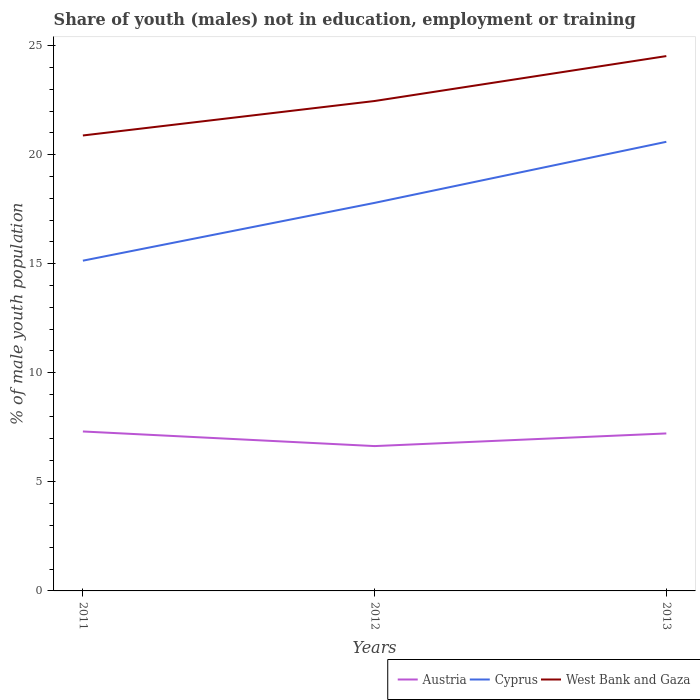Across all years, what is the maximum percentage of unemployed males population in in Austria?
Give a very brief answer. 6.64. What is the total percentage of unemployed males population in in West Bank and Gaza in the graph?
Ensure brevity in your answer.  -3.64. What is the difference between the highest and the second highest percentage of unemployed males population in in Cyprus?
Your answer should be very brief. 5.45. How many lines are there?
Your response must be concise. 3. How many years are there in the graph?
Your answer should be very brief. 3. What is the difference between two consecutive major ticks on the Y-axis?
Provide a succinct answer. 5. Are the values on the major ticks of Y-axis written in scientific E-notation?
Offer a terse response. No. Where does the legend appear in the graph?
Keep it short and to the point. Bottom right. What is the title of the graph?
Keep it short and to the point. Share of youth (males) not in education, employment or training. Does "Aruba" appear as one of the legend labels in the graph?
Provide a succinct answer. No. What is the label or title of the Y-axis?
Ensure brevity in your answer.  % of male youth population. What is the % of male youth population in Austria in 2011?
Offer a terse response. 7.31. What is the % of male youth population in Cyprus in 2011?
Provide a succinct answer. 15.14. What is the % of male youth population of West Bank and Gaza in 2011?
Your answer should be very brief. 20.88. What is the % of male youth population of Austria in 2012?
Ensure brevity in your answer.  6.64. What is the % of male youth population in Cyprus in 2012?
Provide a succinct answer. 17.79. What is the % of male youth population of West Bank and Gaza in 2012?
Offer a terse response. 22.46. What is the % of male youth population in Austria in 2013?
Keep it short and to the point. 7.22. What is the % of male youth population in Cyprus in 2013?
Offer a terse response. 20.59. What is the % of male youth population in West Bank and Gaza in 2013?
Keep it short and to the point. 24.52. Across all years, what is the maximum % of male youth population of Austria?
Your answer should be compact. 7.31. Across all years, what is the maximum % of male youth population in Cyprus?
Keep it short and to the point. 20.59. Across all years, what is the maximum % of male youth population in West Bank and Gaza?
Give a very brief answer. 24.52. Across all years, what is the minimum % of male youth population in Austria?
Provide a short and direct response. 6.64. Across all years, what is the minimum % of male youth population of Cyprus?
Your answer should be very brief. 15.14. Across all years, what is the minimum % of male youth population of West Bank and Gaza?
Give a very brief answer. 20.88. What is the total % of male youth population in Austria in the graph?
Provide a succinct answer. 21.17. What is the total % of male youth population of Cyprus in the graph?
Give a very brief answer. 53.52. What is the total % of male youth population of West Bank and Gaza in the graph?
Your answer should be very brief. 67.86. What is the difference between the % of male youth population in Austria in 2011 and that in 2012?
Your response must be concise. 0.67. What is the difference between the % of male youth population of Cyprus in 2011 and that in 2012?
Your answer should be compact. -2.65. What is the difference between the % of male youth population in West Bank and Gaza in 2011 and that in 2012?
Your answer should be compact. -1.58. What is the difference between the % of male youth population in Austria in 2011 and that in 2013?
Offer a terse response. 0.09. What is the difference between the % of male youth population in Cyprus in 2011 and that in 2013?
Offer a very short reply. -5.45. What is the difference between the % of male youth population of West Bank and Gaza in 2011 and that in 2013?
Provide a succinct answer. -3.64. What is the difference between the % of male youth population in Austria in 2012 and that in 2013?
Your response must be concise. -0.58. What is the difference between the % of male youth population of West Bank and Gaza in 2012 and that in 2013?
Make the answer very short. -2.06. What is the difference between the % of male youth population in Austria in 2011 and the % of male youth population in Cyprus in 2012?
Offer a very short reply. -10.48. What is the difference between the % of male youth population of Austria in 2011 and the % of male youth population of West Bank and Gaza in 2012?
Ensure brevity in your answer.  -15.15. What is the difference between the % of male youth population of Cyprus in 2011 and the % of male youth population of West Bank and Gaza in 2012?
Keep it short and to the point. -7.32. What is the difference between the % of male youth population in Austria in 2011 and the % of male youth population in Cyprus in 2013?
Offer a terse response. -13.28. What is the difference between the % of male youth population in Austria in 2011 and the % of male youth population in West Bank and Gaza in 2013?
Offer a terse response. -17.21. What is the difference between the % of male youth population in Cyprus in 2011 and the % of male youth population in West Bank and Gaza in 2013?
Offer a very short reply. -9.38. What is the difference between the % of male youth population in Austria in 2012 and the % of male youth population in Cyprus in 2013?
Make the answer very short. -13.95. What is the difference between the % of male youth population of Austria in 2012 and the % of male youth population of West Bank and Gaza in 2013?
Give a very brief answer. -17.88. What is the difference between the % of male youth population in Cyprus in 2012 and the % of male youth population in West Bank and Gaza in 2013?
Offer a terse response. -6.73. What is the average % of male youth population in Austria per year?
Provide a short and direct response. 7.06. What is the average % of male youth population of Cyprus per year?
Make the answer very short. 17.84. What is the average % of male youth population of West Bank and Gaza per year?
Provide a succinct answer. 22.62. In the year 2011, what is the difference between the % of male youth population in Austria and % of male youth population in Cyprus?
Provide a short and direct response. -7.83. In the year 2011, what is the difference between the % of male youth population in Austria and % of male youth population in West Bank and Gaza?
Make the answer very short. -13.57. In the year 2011, what is the difference between the % of male youth population of Cyprus and % of male youth population of West Bank and Gaza?
Make the answer very short. -5.74. In the year 2012, what is the difference between the % of male youth population of Austria and % of male youth population of Cyprus?
Your answer should be very brief. -11.15. In the year 2012, what is the difference between the % of male youth population of Austria and % of male youth population of West Bank and Gaza?
Give a very brief answer. -15.82. In the year 2012, what is the difference between the % of male youth population in Cyprus and % of male youth population in West Bank and Gaza?
Give a very brief answer. -4.67. In the year 2013, what is the difference between the % of male youth population of Austria and % of male youth population of Cyprus?
Give a very brief answer. -13.37. In the year 2013, what is the difference between the % of male youth population in Austria and % of male youth population in West Bank and Gaza?
Provide a succinct answer. -17.3. In the year 2013, what is the difference between the % of male youth population of Cyprus and % of male youth population of West Bank and Gaza?
Your answer should be very brief. -3.93. What is the ratio of the % of male youth population of Austria in 2011 to that in 2012?
Your answer should be very brief. 1.1. What is the ratio of the % of male youth population in Cyprus in 2011 to that in 2012?
Your answer should be compact. 0.85. What is the ratio of the % of male youth population in West Bank and Gaza in 2011 to that in 2012?
Offer a terse response. 0.93. What is the ratio of the % of male youth population of Austria in 2011 to that in 2013?
Give a very brief answer. 1.01. What is the ratio of the % of male youth population of Cyprus in 2011 to that in 2013?
Offer a terse response. 0.74. What is the ratio of the % of male youth population in West Bank and Gaza in 2011 to that in 2013?
Offer a terse response. 0.85. What is the ratio of the % of male youth population of Austria in 2012 to that in 2013?
Keep it short and to the point. 0.92. What is the ratio of the % of male youth population of Cyprus in 2012 to that in 2013?
Ensure brevity in your answer.  0.86. What is the ratio of the % of male youth population in West Bank and Gaza in 2012 to that in 2013?
Make the answer very short. 0.92. What is the difference between the highest and the second highest % of male youth population in Austria?
Your answer should be compact. 0.09. What is the difference between the highest and the second highest % of male youth population in Cyprus?
Provide a short and direct response. 2.8. What is the difference between the highest and the second highest % of male youth population in West Bank and Gaza?
Ensure brevity in your answer.  2.06. What is the difference between the highest and the lowest % of male youth population in Austria?
Provide a succinct answer. 0.67. What is the difference between the highest and the lowest % of male youth population in Cyprus?
Make the answer very short. 5.45. What is the difference between the highest and the lowest % of male youth population in West Bank and Gaza?
Make the answer very short. 3.64. 